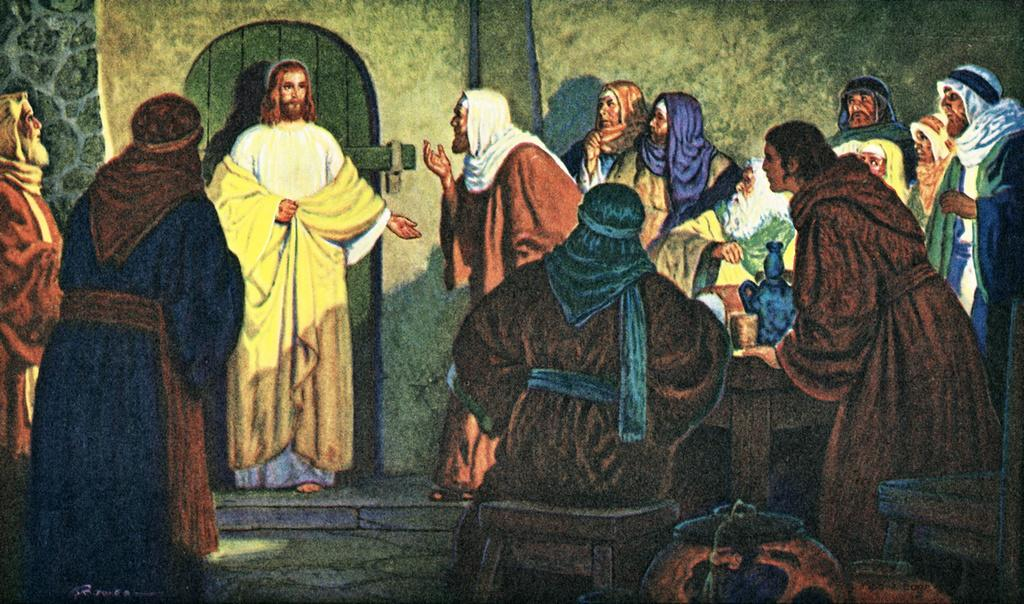What type of artwork is depicted in the image? The image is a painting. What can be seen in the painting? There is a group of people and a table with objects in the painting. What is visible in the background of the painting? There is a door and a wall in the background of the painting. How many cherries are on the table in the painting? There is no mention of cherries in the painting, so we cannot determine the number of cherries present. What type of current is flowing through the wall in the painting? There is no indication of electricity or current in the painting; it is a static image. 